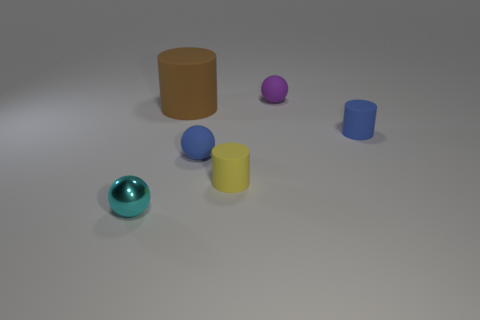Add 3 small rubber balls. How many objects exist? 9 Subtract all large brown cylinders. How many cylinders are left? 2 Subtract all gray spheres. Subtract all green cylinders. How many spheres are left? 3 Add 3 tiny purple objects. How many tiny purple objects are left? 4 Add 4 large brown rubber cylinders. How many large brown rubber cylinders exist? 5 Subtract 1 brown cylinders. How many objects are left? 5 Subtract all big brown cylinders. Subtract all small rubber cylinders. How many objects are left? 3 